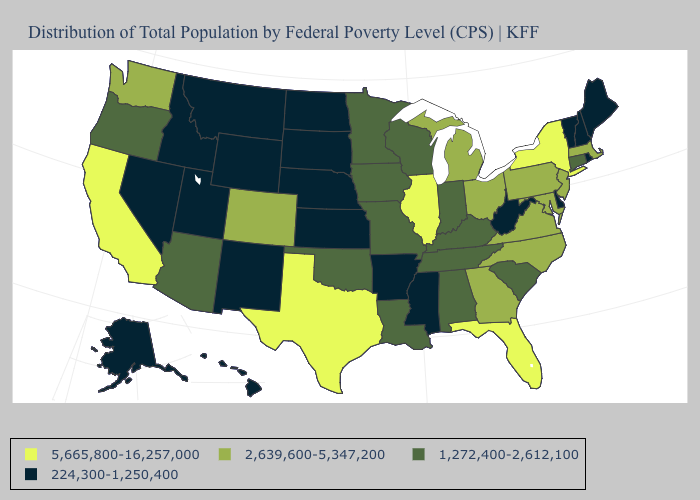Name the states that have a value in the range 1,272,400-2,612,100?
Short answer required. Alabama, Arizona, Connecticut, Indiana, Iowa, Kentucky, Louisiana, Minnesota, Missouri, Oklahoma, Oregon, South Carolina, Tennessee, Wisconsin. Does California have the highest value in the USA?
Quick response, please. Yes. Among the states that border Kentucky , does West Virginia have the lowest value?
Write a very short answer. Yes. Name the states that have a value in the range 224,300-1,250,400?
Write a very short answer. Alaska, Arkansas, Delaware, Hawaii, Idaho, Kansas, Maine, Mississippi, Montana, Nebraska, Nevada, New Hampshire, New Mexico, North Dakota, Rhode Island, South Dakota, Utah, Vermont, West Virginia, Wyoming. What is the lowest value in the USA?
Give a very brief answer. 224,300-1,250,400. What is the value of South Dakota?
Keep it brief. 224,300-1,250,400. What is the value of Maine?
Give a very brief answer. 224,300-1,250,400. Name the states that have a value in the range 1,272,400-2,612,100?
Write a very short answer. Alabama, Arizona, Connecticut, Indiana, Iowa, Kentucky, Louisiana, Minnesota, Missouri, Oklahoma, Oregon, South Carolina, Tennessee, Wisconsin. Among the states that border Tennessee , which have the lowest value?
Keep it brief. Arkansas, Mississippi. Does New Mexico have the lowest value in the USA?
Write a very short answer. Yes. Name the states that have a value in the range 2,639,600-5,347,200?
Quick response, please. Colorado, Georgia, Maryland, Massachusetts, Michigan, New Jersey, North Carolina, Ohio, Pennsylvania, Virginia, Washington. What is the value of Wyoming?
Give a very brief answer. 224,300-1,250,400. What is the value of New Mexico?
Quick response, please. 224,300-1,250,400. Among the states that border Arizona , which have the lowest value?
Short answer required. Nevada, New Mexico, Utah. Name the states that have a value in the range 2,639,600-5,347,200?
Concise answer only. Colorado, Georgia, Maryland, Massachusetts, Michigan, New Jersey, North Carolina, Ohio, Pennsylvania, Virginia, Washington. 